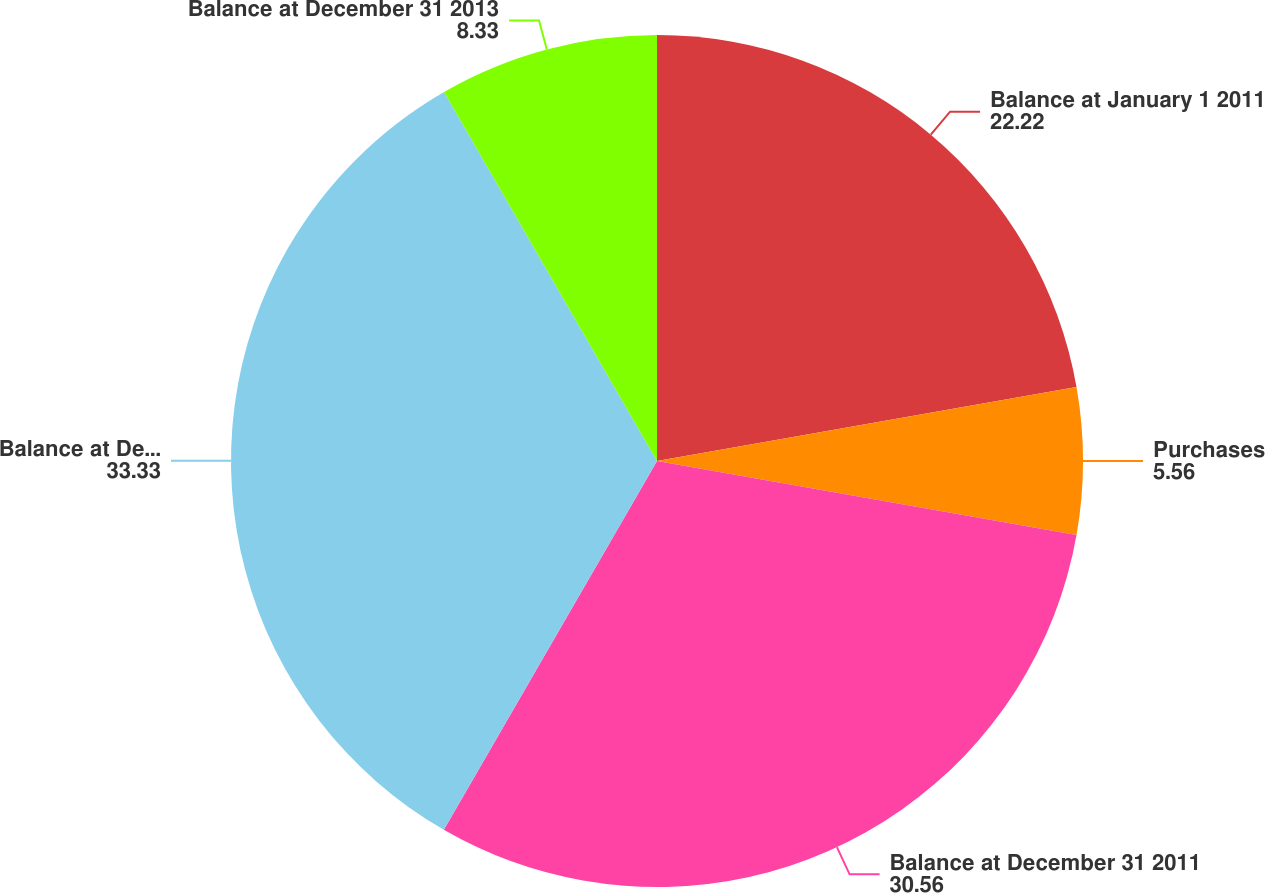Convert chart. <chart><loc_0><loc_0><loc_500><loc_500><pie_chart><fcel>Balance at January 1 2011<fcel>Purchases<fcel>Balance at December 31 2011<fcel>Balance at December 31 2012<fcel>Balance at December 31 2013<nl><fcel>22.22%<fcel>5.56%<fcel>30.56%<fcel>33.33%<fcel>8.33%<nl></chart> 